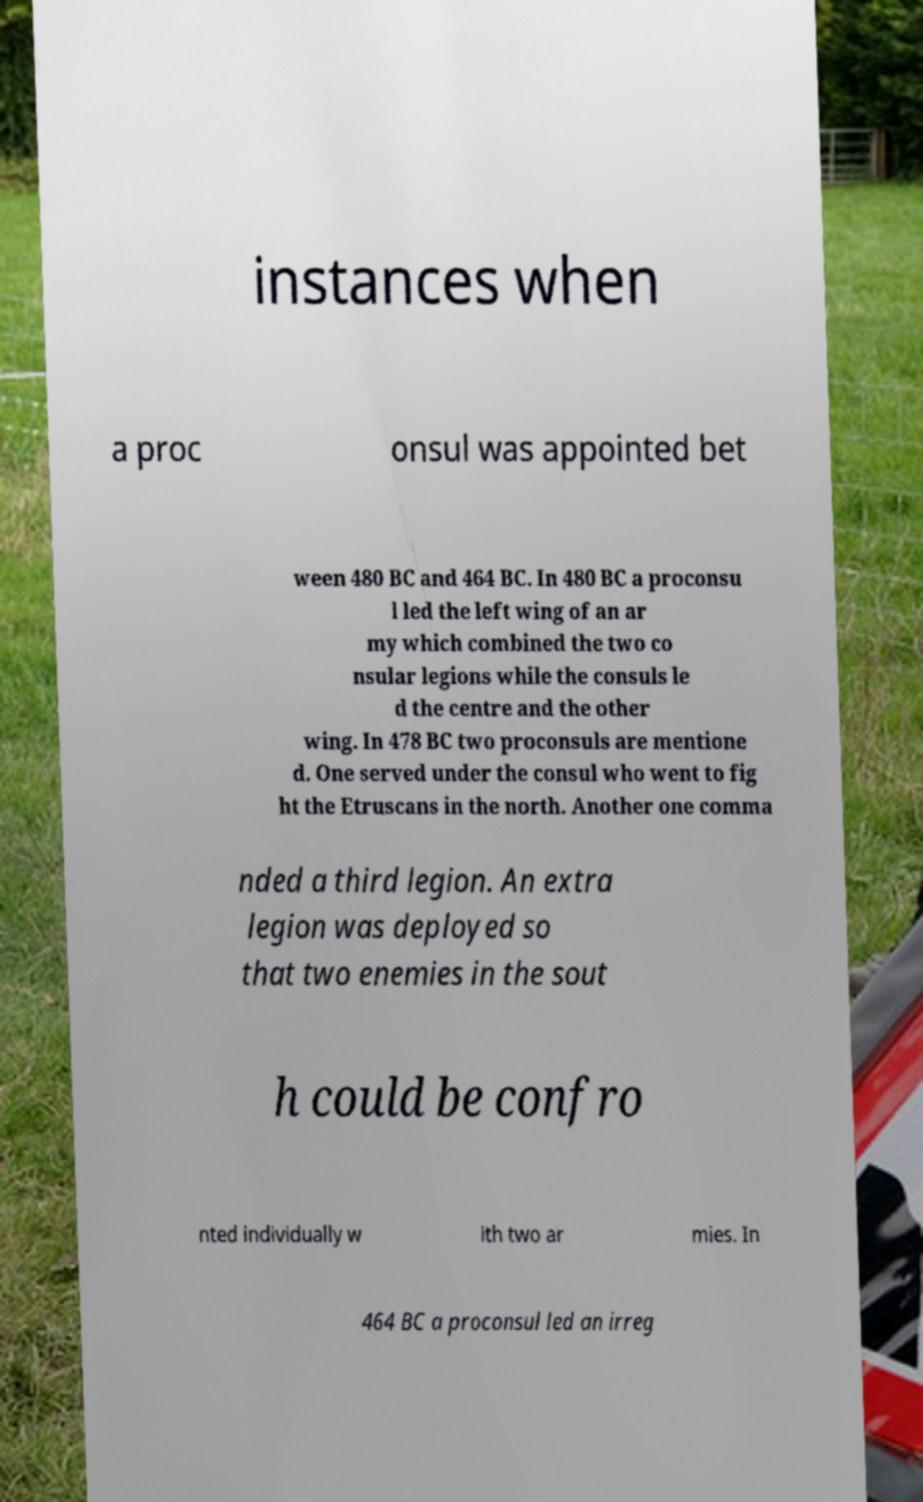Can you read and provide the text displayed in the image?This photo seems to have some interesting text. Can you extract and type it out for me? instances when a proc onsul was appointed bet ween 480 BC and 464 BC. In 480 BC a proconsu l led the left wing of an ar my which combined the two co nsular legions while the consuls le d the centre and the other wing. In 478 BC two proconsuls are mentione d. One served under the consul who went to fig ht the Etruscans in the north. Another one comma nded a third legion. An extra legion was deployed so that two enemies in the sout h could be confro nted individually w ith two ar mies. In 464 BC a proconsul led an irreg 